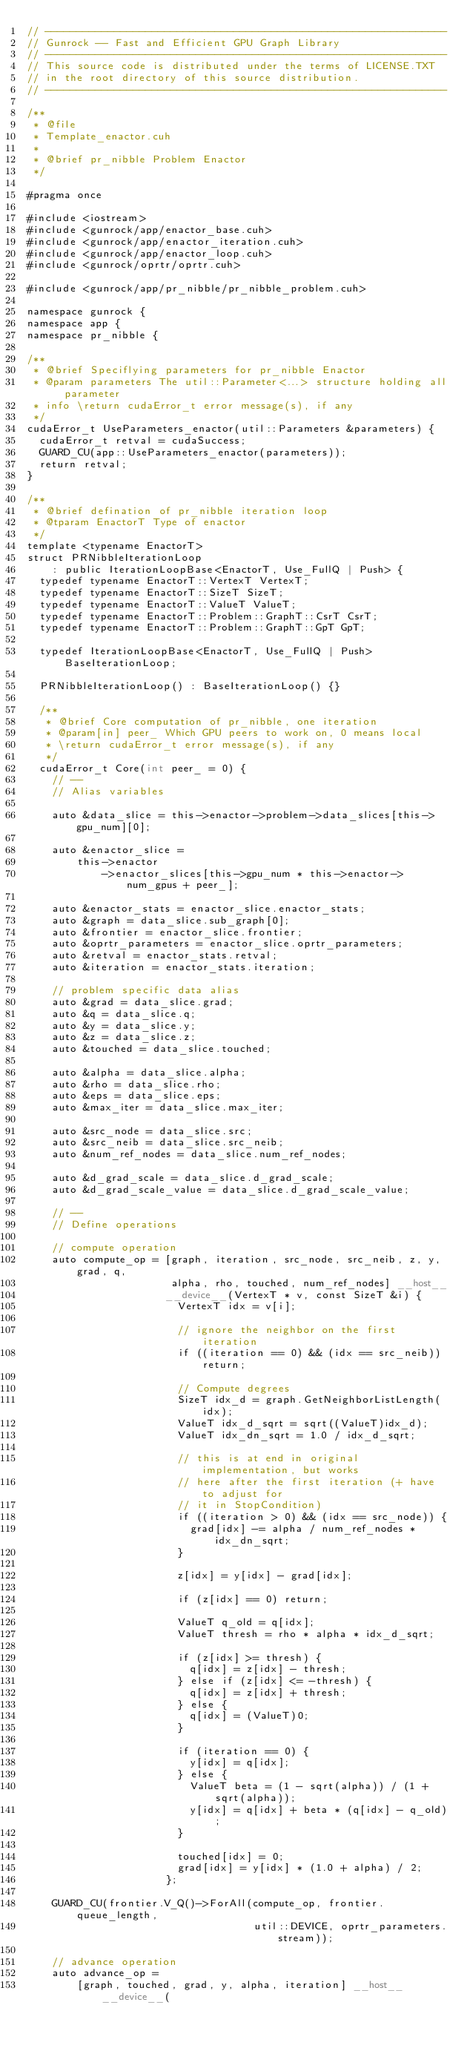<code> <loc_0><loc_0><loc_500><loc_500><_Cuda_>// ----------------------------------------------------------------
// Gunrock -- Fast and Efficient GPU Graph Library
// ----------------------------------------------------------------
// This source code is distributed under the terms of LICENSE.TXT
// in the root directory of this source distribution.
// ----------------------------------------------------------------

/**
 * @file
 * Template_enactor.cuh
 *
 * @brief pr_nibble Problem Enactor
 */

#pragma once

#include <iostream>
#include <gunrock/app/enactor_base.cuh>
#include <gunrock/app/enactor_iteration.cuh>
#include <gunrock/app/enactor_loop.cuh>
#include <gunrock/oprtr/oprtr.cuh>

#include <gunrock/app/pr_nibble/pr_nibble_problem.cuh>

namespace gunrock {
namespace app {
namespace pr_nibble {

/**
 * @brief Speciflying parameters for pr_nibble Enactor
 * @param parameters The util::Parameter<...> structure holding all parameter
 * info \return cudaError_t error message(s), if any
 */
cudaError_t UseParameters_enactor(util::Parameters &parameters) {
  cudaError_t retval = cudaSuccess;
  GUARD_CU(app::UseParameters_enactor(parameters));
  return retval;
}

/**
 * @brief defination of pr_nibble iteration loop
 * @tparam EnactorT Type of enactor
 */
template <typename EnactorT>
struct PRNibbleIterationLoop
    : public IterationLoopBase<EnactorT, Use_FullQ | Push> {
  typedef typename EnactorT::VertexT VertexT;
  typedef typename EnactorT::SizeT SizeT;
  typedef typename EnactorT::ValueT ValueT;
  typedef typename EnactorT::Problem::GraphT::CsrT CsrT;
  typedef typename EnactorT::Problem::GraphT::GpT GpT;

  typedef IterationLoopBase<EnactorT, Use_FullQ | Push> BaseIterationLoop;

  PRNibbleIterationLoop() : BaseIterationLoop() {}

  /**
   * @brief Core computation of pr_nibble, one iteration
   * @param[in] peer_ Which GPU peers to work on, 0 means local
   * \return cudaError_t error message(s), if any
   */
  cudaError_t Core(int peer_ = 0) {
    // --
    // Alias variables

    auto &data_slice = this->enactor->problem->data_slices[this->gpu_num][0];

    auto &enactor_slice =
        this->enactor
            ->enactor_slices[this->gpu_num * this->enactor->num_gpus + peer_];

    auto &enactor_stats = enactor_slice.enactor_stats;
    auto &graph = data_slice.sub_graph[0];
    auto &frontier = enactor_slice.frontier;
    auto &oprtr_parameters = enactor_slice.oprtr_parameters;
    auto &retval = enactor_stats.retval;
    auto &iteration = enactor_stats.iteration;

    // problem specific data alias
    auto &grad = data_slice.grad;
    auto &q = data_slice.q;
    auto &y = data_slice.y;
    auto &z = data_slice.z;
    auto &touched = data_slice.touched;

    auto &alpha = data_slice.alpha;
    auto &rho = data_slice.rho;
    auto &eps = data_slice.eps;
    auto &max_iter = data_slice.max_iter;

    auto &src_node = data_slice.src;
    auto &src_neib = data_slice.src_neib;
    auto &num_ref_nodes = data_slice.num_ref_nodes;

    auto &d_grad_scale = data_slice.d_grad_scale;
    auto &d_grad_scale_value = data_slice.d_grad_scale_value;

    // --
    // Define operations

    // compute operation
    auto compute_op = [graph, iteration, src_node, src_neib, z, y, grad, q,
                       alpha, rho, touched, num_ref_nodes] __host__
                      __device__(VertexT * v, const SizeT &i) {
                        VertexT idx = v[i];

                        // ignore the neighbor on the first iteration
                        if ((iteration == 0) && (idx == src_neib)) return;

                        // Compute degrees
                        SizeT idx_d = graph.GetNeighborListLength(idx);
                        ValueT idx_d_sqrt = sqrt((ValueT)idx_d);
                        ValueT idx_dn_sqrt = 1.0 / idx_d_sqrt;

                        // this is at end in original implementation, but works
                        // here after the first iteration (+ have to adjust for
                        // it in StopCondition)
                        if ((iteration > 0) && (idx == src_node)) {
                          grad[idx] -= alpha / num_ref_nodes * idx_dn_sqrt;
                        }

                        z[idx] = y[idx] - grad[idx];

                        if (z[idx] == 0) return;

                        ValueT q_old = q[idx];
                        ValueT thresh = rho * alpha * idx_d_sqrt;

                        if (z[idx] >= thresh) {
                          q[idx] = z[idx] - thresh;
                        } else if (z[idx] <= -thresh) {
                          q[idx] = z[idx] + thresh;
                        } else {
                          q[idx] = (ValueT)0;
                        }

                        if (iteration == 0) {
                          y[idx] = q[idx];
                        } else {
                          ValueT beta = (1 - sqrt(alpha)) / (1 + sqrt(alpha));
                          y[idx] = q[idx] + beta * (q[idx] - q_old);
                        }

                        touched[idx] = 0;
                        grad[idx] = y[idx] * (1.0 + alpha) / 2;
                      };

    GUARD_CU(frontier.V_Q()->ForAll(compute_op, frontier.queue_length,
                                    util::DEVICE, oprtr_parameters.stream));

    // advance operation
    auto advance_op =
        [graph, touched, grad, y, alpha, iteration] __host__ __device__(</code> 